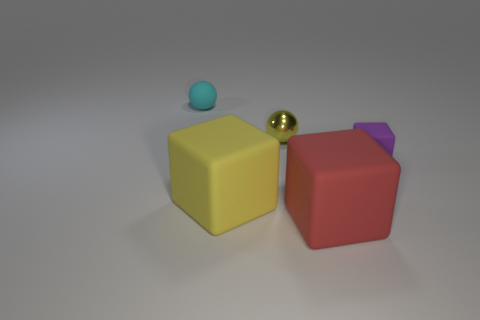Is there any other thing that has the same material as the small yellow sphere?
Keep it short and to the point. No. What is the material of the red thing that is the same shape as the purple thing?
Your response must be concise. Rubber. Do the red block and the small cyan sphere have the same material?
Your answer should be compact. Yes. There is a rubber thing that is behind the sphere that is in front of the small cyan object; what is its color?
Ensure brevity in your answer.  Cyan. The yellow cube that is the same material as the tiny cyan ball is what size?
Your response must be concise. Large. How many other small objects are the same shape as the tiny purple rubber thing?
Offer a terse response. 0. How many things are tiny matte things that are in front of the tiny matte ball or rubber objects to the left of the tiny metallic ball?
Your answer should be very brief. 3. There is a yellow thing behind the big yellow block; how many yellow balls are right of it?
Your answer should be very brief. 0. There is a thing that is behind the metallic ball; is it the same shape as the small rubber object to the right of the small matte ball?
Keep it short and to the point. No. The matte object that is the same color as the tiny shiny ball is what shape?
Your response must be concise. Cube. 